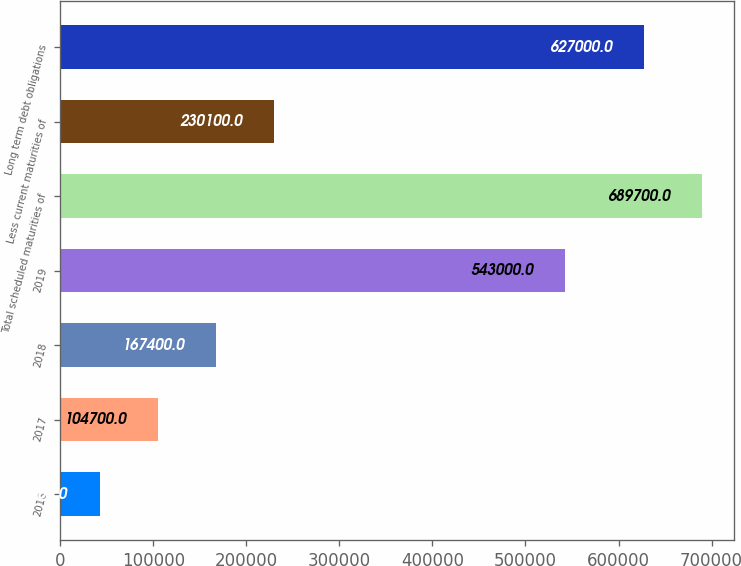Convert chart to OTSL. <chart><loc_0><loc_0><loc_500><loc_500><bar_chart><fcel>2016<fcel>2017<fcel>2018<fcel>2019<fcel>Total scheduled maturities of<fcel>Less current maturities of<fcel>Long term debt obligations<nl><fcel>42000<fcel>104700<fcel>167400<fcel>543000<fcel>689700<fcel>230100<fcel>627000<nl></chart> 